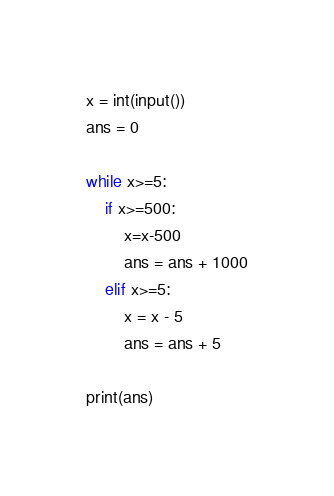<code> <loc_0><loc_0><loc_500><loc_500><_Python_>x = int(input())
ans = 0

while x>=5:
    if x>=500:
        x=x-500
        ans = ans + 1000
    elif x>=5:
        x = x - 5
        ans = ans + 5

print(ans)</code> 